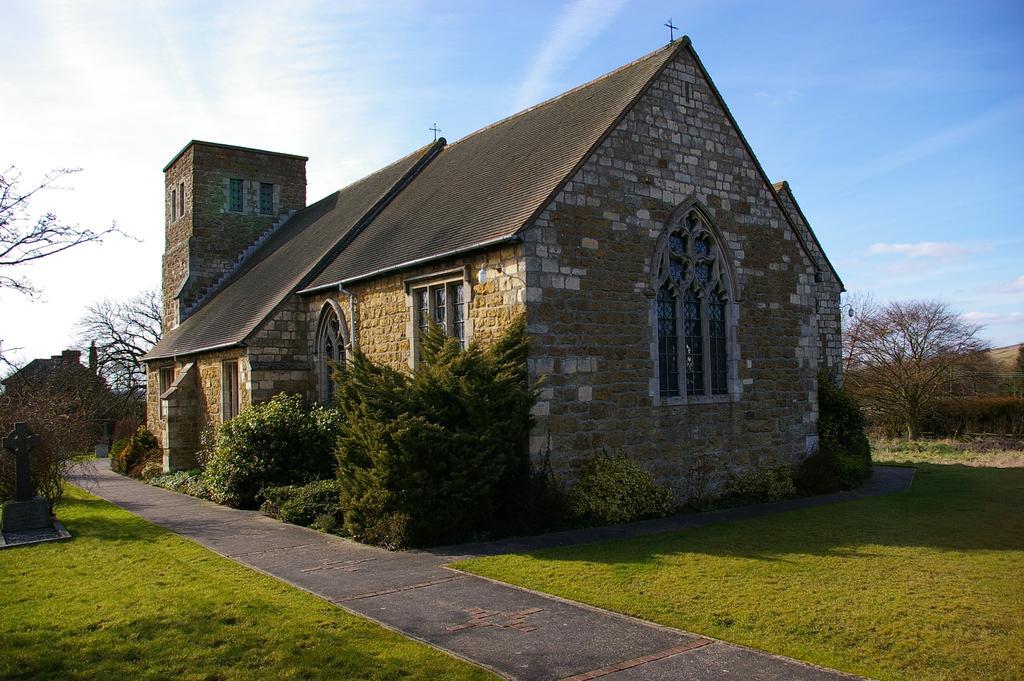Can you describe this image briefly? In the center of the image we can see a building with group of windows and plants. To the left side of the image we can see a statue on the ground, In the background, we can see a building, group of trees and the sky. 